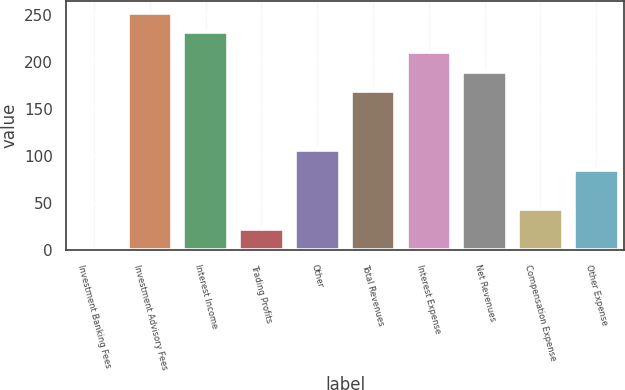Convert chart to OTSL. <chart><loc_0><loc_0><loc_500><loc_500><bar_chart><fcel>Investment Banking Fees<fcel>Investment Advisory Fees<fcel>Interest Income<fcel>Trading Profits<fcel>Other<fcel>Total Revenues<fcel>Interest Expense<fcel>Net Revenues<fcel>Compensation Expense<fcel>Other Expense<nl><fcel>2<fcel>252.8<fcel>231.9<fcel>22.9<fcel>106.5<fcel>169.2<fcel>211<fcel>190.1<fcel>43.8<fcel>85.6<nl></chart> 